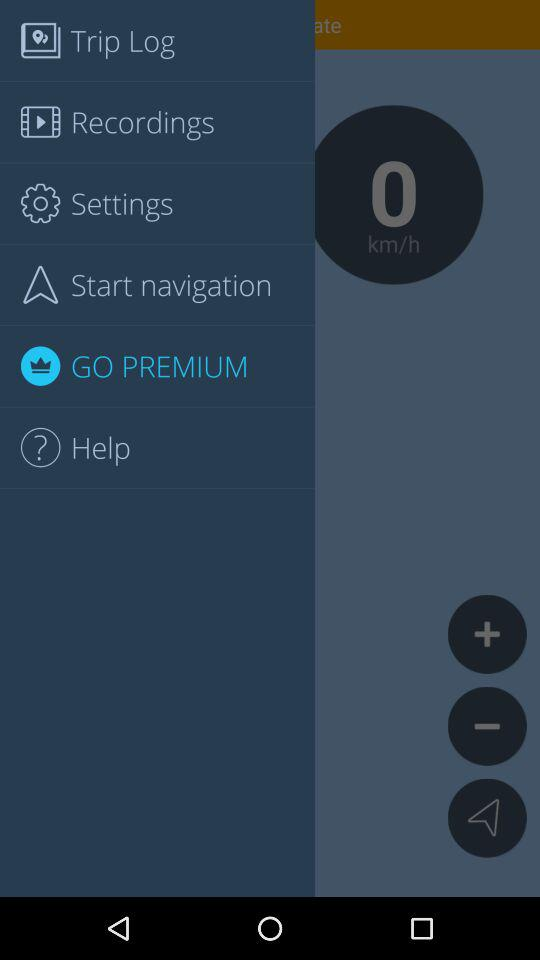Which item is selected in the menu? The item "GO PREMIUM" is selected in the menu. 